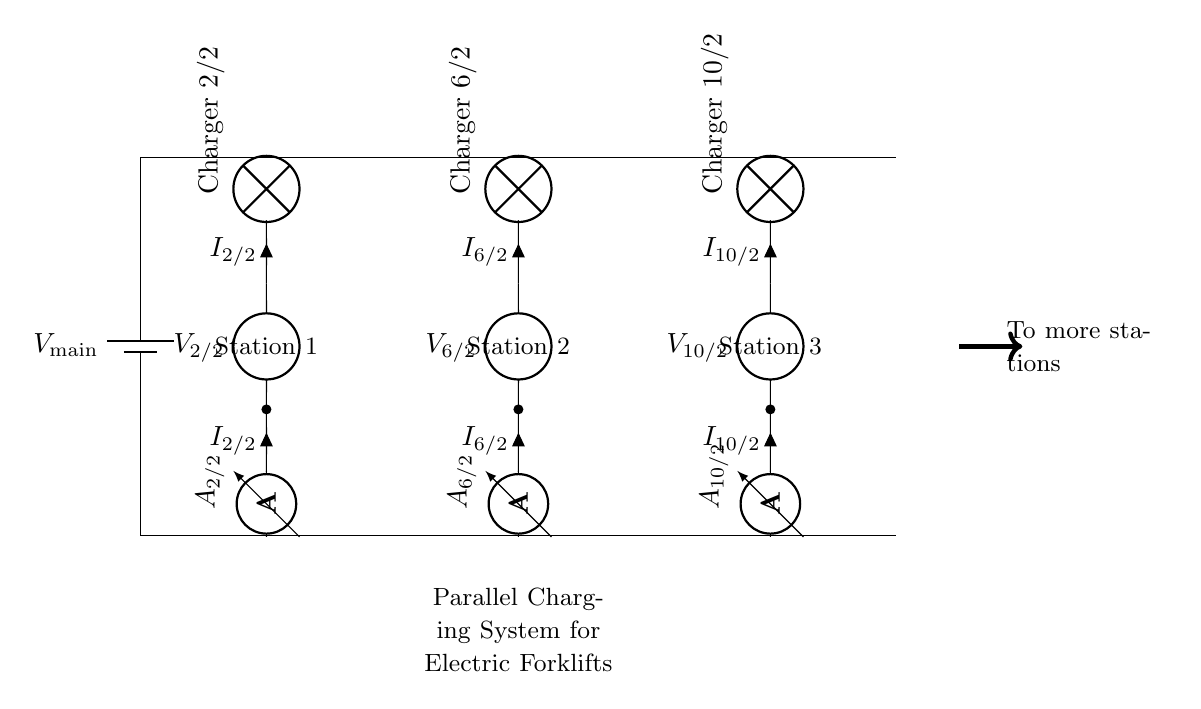What is the total number of charging stations? The circuit diagram displays three charging stations labeled as Station 1, Station 2, and Station 3, indicating that there are three distinct charging points in the parallel system.
Answer: three What component measures the current at each charging station? Each charging station has an ammeter connected in series, which is specifically designed to measure the current flowing through the circuit, hence identifying the component responsible for current measurement.
Answer: ammeter What is the voltage source representing in the circuit? The voltage source, labeled as V main, indicates the supply voltage for the entire parallel charging system, representing the power source that provides the required electrical energy to charge the forklifts.
Answer: V main How are the charging stations connected to the voltage source? The charging stations are each connected in parallel, meaning they share the same two voltage supply lines, resulting in each station receiving the same voltage from the main source.
Answer: in parallel If the current at Station 2 is 4 Amperes, what would the current be at Station 3 if it is known they share the same supply current? Given that the charging stations are connected in parallel, the total current supplied (which is the sum of the currents through each station) remains the same. Therefore, if Station 2 draws 4 Amperes, Station 3 can be calculated based on the total current divided among the stations, assuming regulations from previous stations. If not defined, it cannot be determined without additional information.
Answer: cannot be determined What are the potential implications of the charging system being parallel versus series? A parallel circuit allows multiple components to draw current independently from the voltage source, meaning if one charging station fails, it does not affect the others. On the other hand, in a series circuit, a failure in one component could disrupt the entire circuit. Hence, the parallel configuration enhances reliability and efficiency for multiple charging stations.
Answer: enhanced reliability and efficiency 